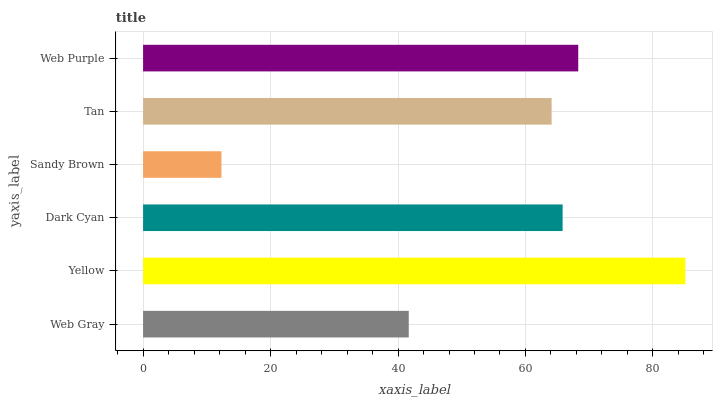Is Sandy Brown the minimum?
Answer yes or no. Yes. Is Yellow the maximum?
Answer yes or no. Yes. Is Dark Cyan the minimum?
Answer yes or no. No. Is Dark Cyan the maximum?
Answer yes or no. No. Is Yellow greater than Dark Cyan?
Answer yes or no. Yes. Is Dark Cyan less than Yellow?
Answer yes or no. Yes. Is Dark Cyan greater than Yellow?
Answer yes or no. No. Is Yellow less than Dark Cyan?
Answer yes or no. No. Is Dark Cyan the high median?
Answer yes or no. Yes. Is Tan the low median?
Answer yes or no. Yes. Is Web Purple the high median?
Answer yes or no. No. Is Web Purple the low median?
Answer yes or no. No. 